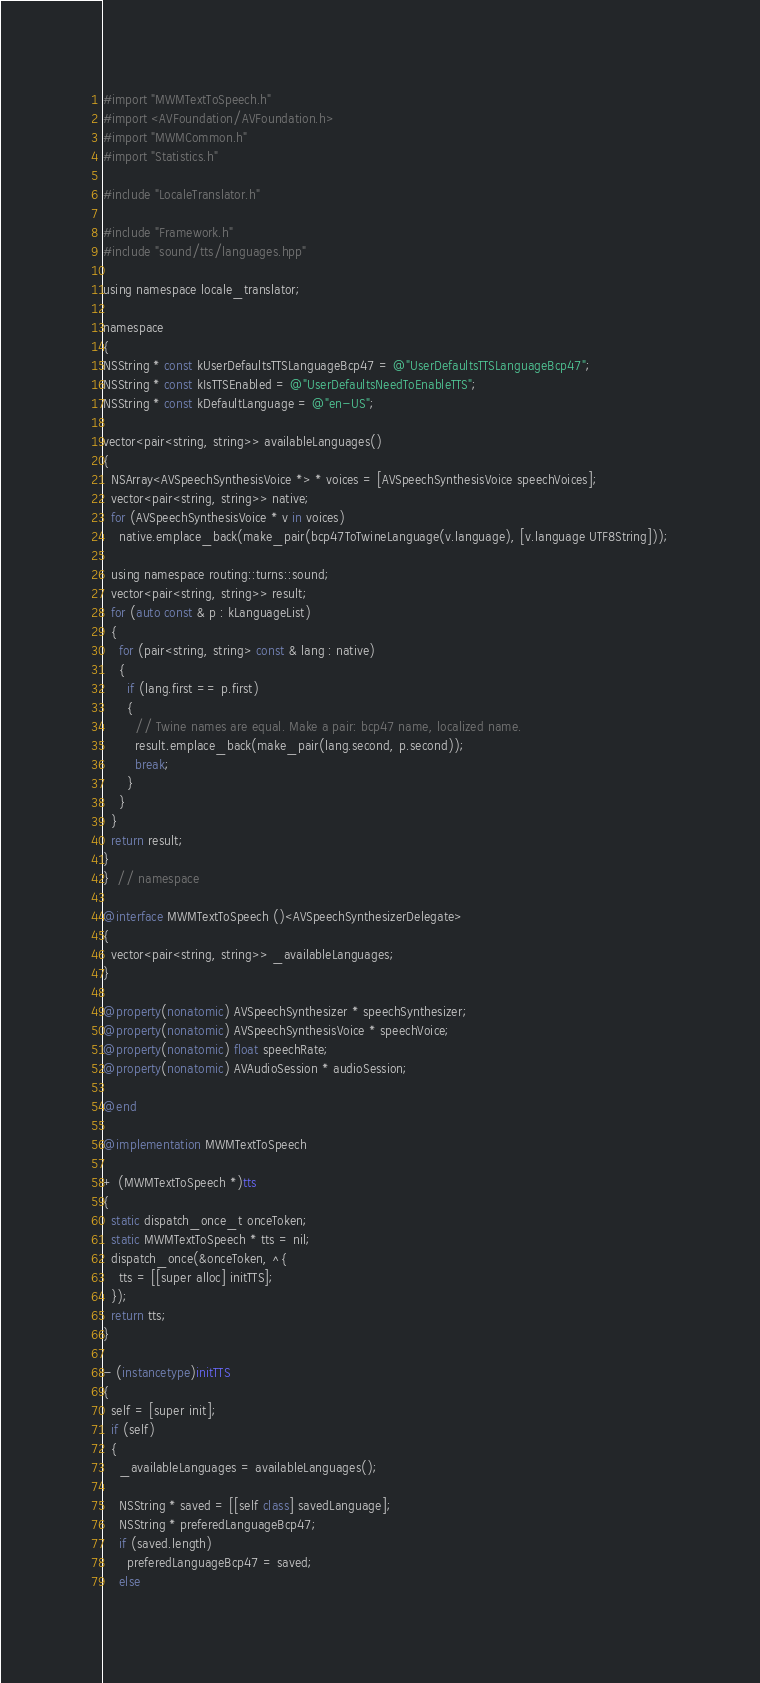Convert code to text. <code><loc_0><loc_0><loc_500><loc_500><_ObjectiveC_>#import "MWMTextToSpeech.h"
#import <AVFoundation/AVFoundation.h>
#import "MWMCommon.h"
#import "Statistics.h"

#include "LocaleTranslator.h"

#include "Framework.h"
#include "sound/tts/languages.hpp"

using namespace locale_translator;

namespace
{
NSString * const kUserDefaultsTTSLanguageBcp47 = @"UserDefaultsTTSLanguageBcp47";
NSString * const kIsTTSEnabled = @"UserDefaultsNeedToEnableTTS";
NSString * const kDefaultLanguage = @"en-US";

vector<pair<string, string>> availableLanguages()
{
  NSArray<AVSpeechSynthesisVoice *> * voices = [AVSpeechSynthesisVoice speechVoices];
  vector<pair<string, string>> native;
  for (AVSpeechSynthesisVoice * v in voices)
    native.emplace_back(make_pair(bcp47ToTwineLanguage(v.language), [v.language UTF8String]));

  using namespace routing::turns::sound;
  vector<pair<string, string>> result;
  for (auto const & p : kLanguageList)
  {
    for (pair<string, string> const & lang : native)
    {
      if (lang.first == p.first)
      {
        // Twine names are equal. Make a pair: bcp47 name, localized name.
        result.emplace_back(make_pair(lang.second, p.second));
        break;
      }
    }
  }
  return result;
}
}  // namespace

@interface MWMTextToSpeech ()<AVSpeechSynthesizerDelegate>
{
  vector<pair<string, string>> _availableLanguages;
}

@property(nonatomic) AVSpeechSynthesizer * speechSynthesizer;
@property(nonatomic) AVSpeechSynthesisVoice * speechVoice;
@property(nonatomic) float speechRate;
@property(nonatomic) AVAudioSession * audioSession;

@end

@implementation MWMTextToSpeech

+ (MWMTextToSpeech *)tts
{
  static dispatch_once_t onceToken;
  static MWMTextToSpeech * tts = nil;
  dispatch_once(&onceToken, ^{
    tts = [[super alloc] initTTS];
  });
  return tts;
}

- (instancetype)initTTS
{
  self = [super init];
  if (self)
  {
    _availableLanguages = availableLanguages();

    NSString * saved = [[self class] savedLanguage];
    NSString * preferedLanguageBcp47;
    if (saved.length)
      preferedLanguageBcp47 = saved;
    else</code> 